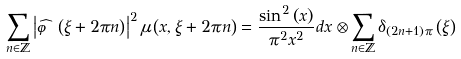<formula> <loc_0><loc_0><loc_500><loc_500>\sum _ { n \in \mathbb { Z } } \left | \widehat { \varphi } \left ( \xi + 2 \pi n \right ) \right | ^ { 2 } \mu \left ( x , \xi + 2 \pi n \right ) = \frac { \sin ^ { 2 } \left ( x \right ) } { \pi ^ { 2 } x ^ { 2 } } d x \otimes \sum _ { n \in \mathbb { Z } } \delta _ { \left ( 2 n + 1 \right ) \pi } \left ( \xi \right )</formula> 